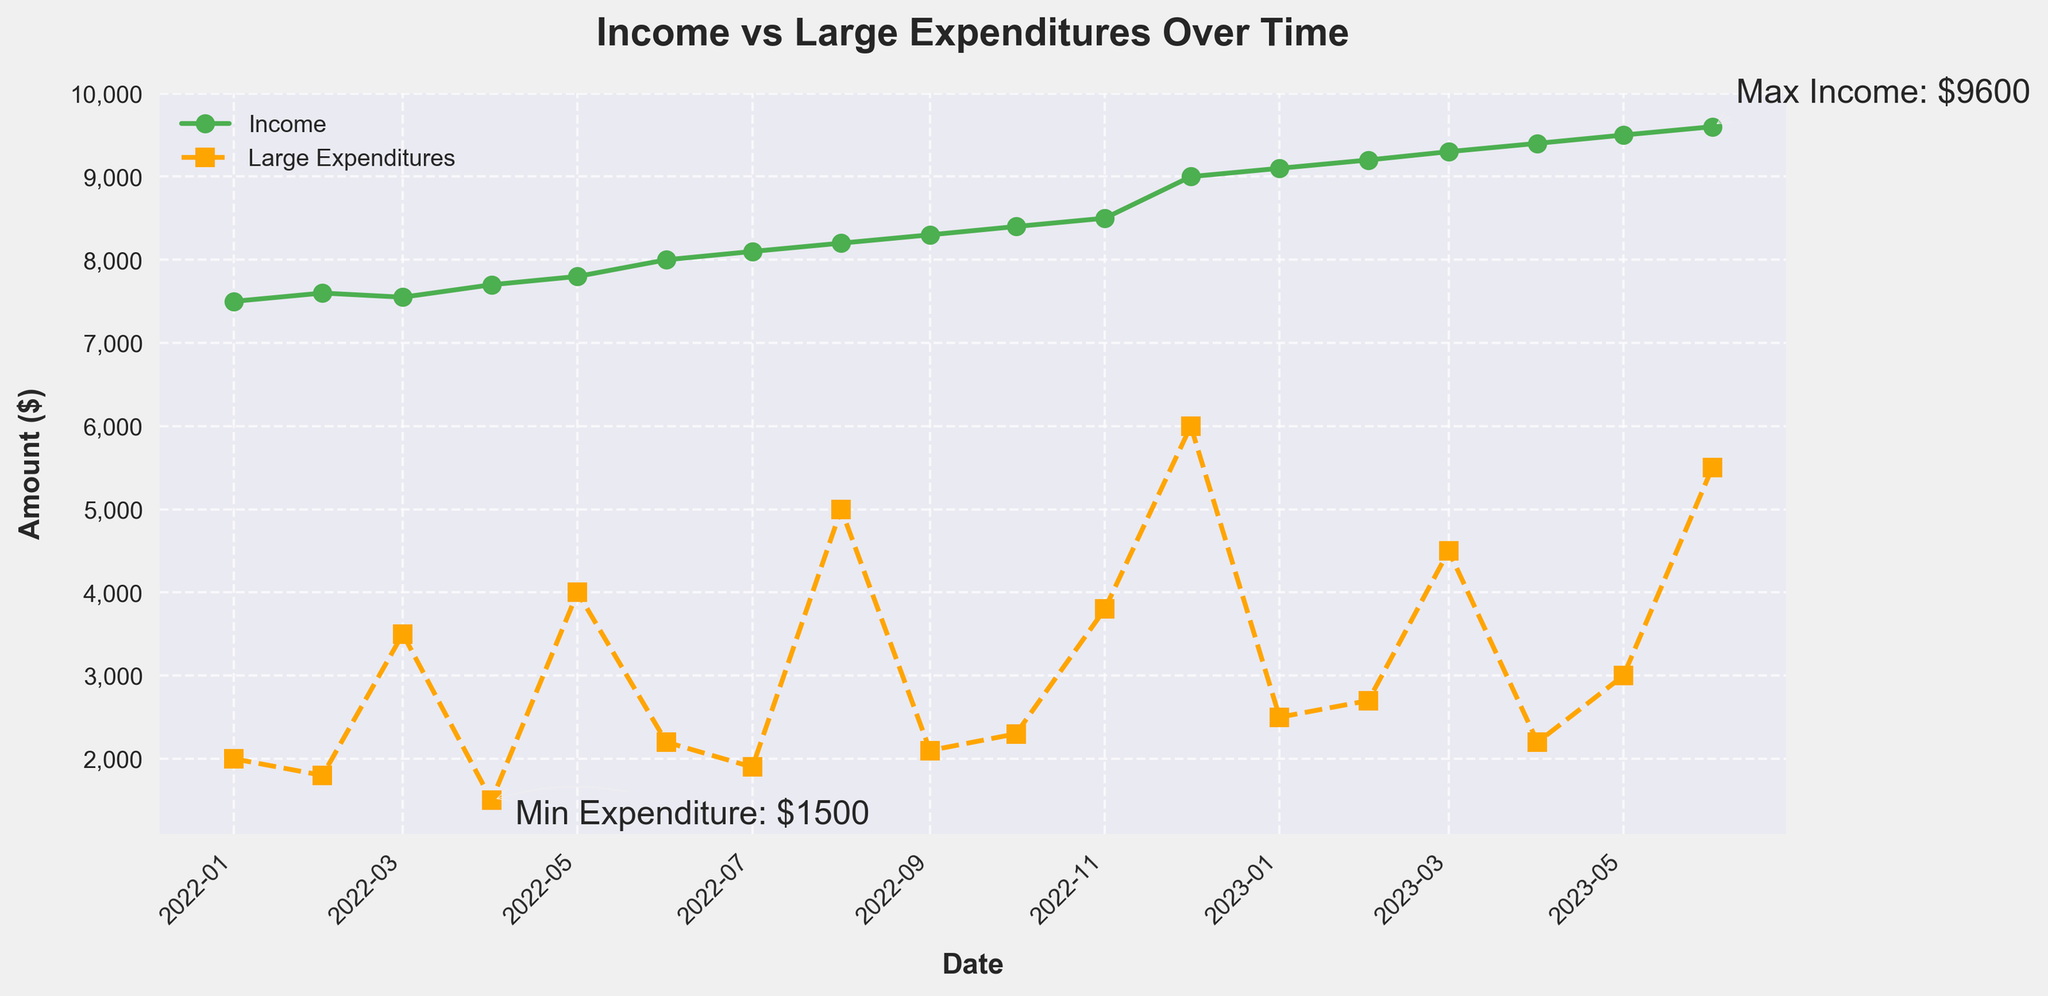What is the maximum income in the time period shown? The maximum income can be identified by locating the highest point of the line representing income on the figure. The annotated text "Max Income: $9600" indicates the maximum income.
Answer: $9600 During which month did the lowest large expenditure occur? The lowest large expenditure can be identified by finding the lowest point on the line representing large expenditures. The annotated text "Min Expenditure: $1500" is over the date "2022-04-01", indicating that April 2022 had the lowest large expenditure.
Answer: April 2022 What is the total income for the first quarter of 2023? Sum the income values for January, February, and March of 2023: $9100 (Jan) + $9200 (Feb) + $9300 (Mar). This results in a total income of $27,600.
Answer: $27,600 Compare the income between June 2022 and December 2022, which one is higher and by how much? The income for June 2022 is $8000 and for December 2022 it is $9000. The difference is $9000 - $8000. Therefore, December 2022 has a $1000 higher income.
Answer: December, $1000 higher Identify the month when both income and large expenditures reached their highest points in the respective period. The highest income is $9600 in June 2023, and the highest expenditure is $6000 in December 2022. No single month has both values reaching their maximum.
Answer: N/A Between which two consecutive months did income increase the most? By calculating the income differences between consecutive months, the largest increase is found between November 2022 ($8500) and December 2022 ($9000), which is $500.
Answer: Between November and December 2022 How does the pattern of large expenditures in the second half of 2022 compare to that in the first half? Visually comparing the expenditure lines, the expenditures are generally higher in the second half of 2022. For example, May ($4000), August ($5000), November ($3800), and December ($6000) have larger expenditures compared to the months in the first half of the year.
Answer: Higher in the second half What is the average large expenditure for the year 2022? Summing all 12 monthly large expenditures for 2022 and dividing by 12: (2000+1800+3500+1500+4000+2200+1900+5000+2100+2300+3800+6000)/12 yields approximately $2958.33.
Answer: $2958.33 